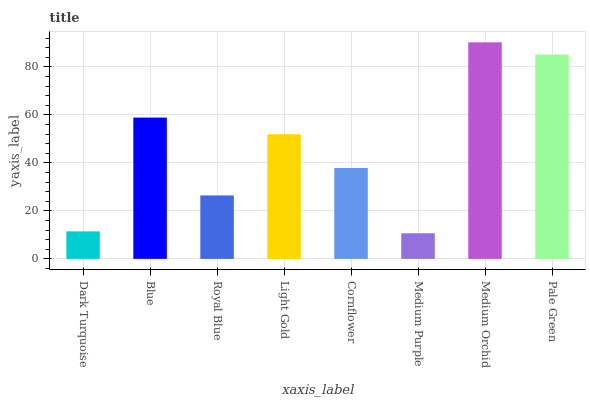Is Medium Purple the minimum?
Answer yes or no. Yes. Is Medium Orchid the maximum?
Answer yes or no. Yes. Is Blue the minimum?
Answer yes or no. No. Is Blue the maximum?
Answer yes or no. No. Is Blue greater than Dark Turquoise?
Answer yes or no. Yes. Is Dark Turquoise less than Blue?
Answer yes or no. Yes. Is Dark Turquoise greater than Blue?
Answer yes or no. No. Is Blue less than Dark Turquoise?
Answer yes or no. No. Is Light Gold the high median?
Answer yes or no. Yes. Is Cornflower the low median?
Answer yes or no. Yes. Is Cornflower the high median?
Answer yes or no. No. Is Light Gold the low median?
Answer yes or no. No. 